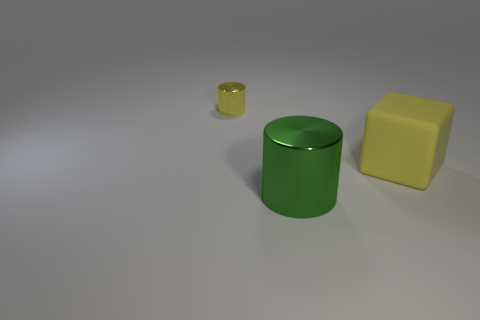Is there anything else that is the same size as the cube?
Offer a very short reply. Yes. Is the size of the yellow cylinder the same as the green shiny thing?
Offer a very short reply. No. Is there a big cube of the same color as the small cylinder?
Your answer should be very brief. Yes. Do the big object behind the big green metallic object and the big green metal thing have the same shape?
Provide a short and direct response. No. How many yellow matte blocks have the same size as the yellow matte thing?
Offer a very short reply. 0. How many large green metallic objects are right of the shiny cylinder that is behind the big yellow block?
Provide a short and direct response. 1. Is the large thing in front of the cube made of the same material as the small cylinder?
Your answer should be very brief. Yes. Are the large object that is behind the green cylinder and the yellow object that is on the left side of the big metallic thing made of the same material?
Your answer should be compact. No. Is the number of big metallic things right of the green shiny cylinder greater than the number of tiny cylinders?
Your answer should be very brief. No. What color is the metallic cylinder behind the big object that is in front of the block?
Give a very brief answer. Yellow. 